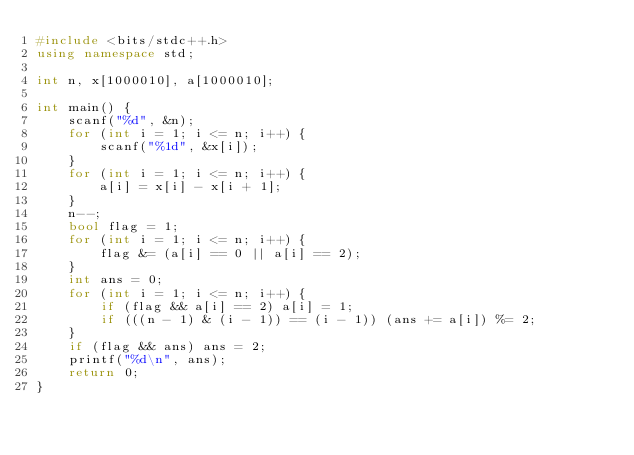Convert code to text. <code><loc_0><loc_0><loc_500><loc_500><_C++_>#include <bits/stdc++.h>
using namespace std;

int n, x[1000010], a[1000010];

int main() {
    scanf("%d", &n);
    for (int i = 1; i <= n; i++) {
        scanf("%1d", &x[i]);
    }
    for (int i = 1; i <= n; i++) {
        a[i] = x[i] - x[i + 1];
    }
    n--;
    bool flag = 1;
    for (int i = 1; i <= n; i++) {
        flag &= (a[i] == 0 || a[i] == 2);
    }
    int ans = 0;
    for (int i = 1; i <= n; i++) {
        if (flag && a[i] == 2) a[i] = 1;
        if (((n - 1) & (i - 1)) == (i - 1)) (ans += a[i]) %= 2;
    }
    if (flag && ans) ans = 2;
    printf("%d\n", ans);
    return 0;
}</code> 